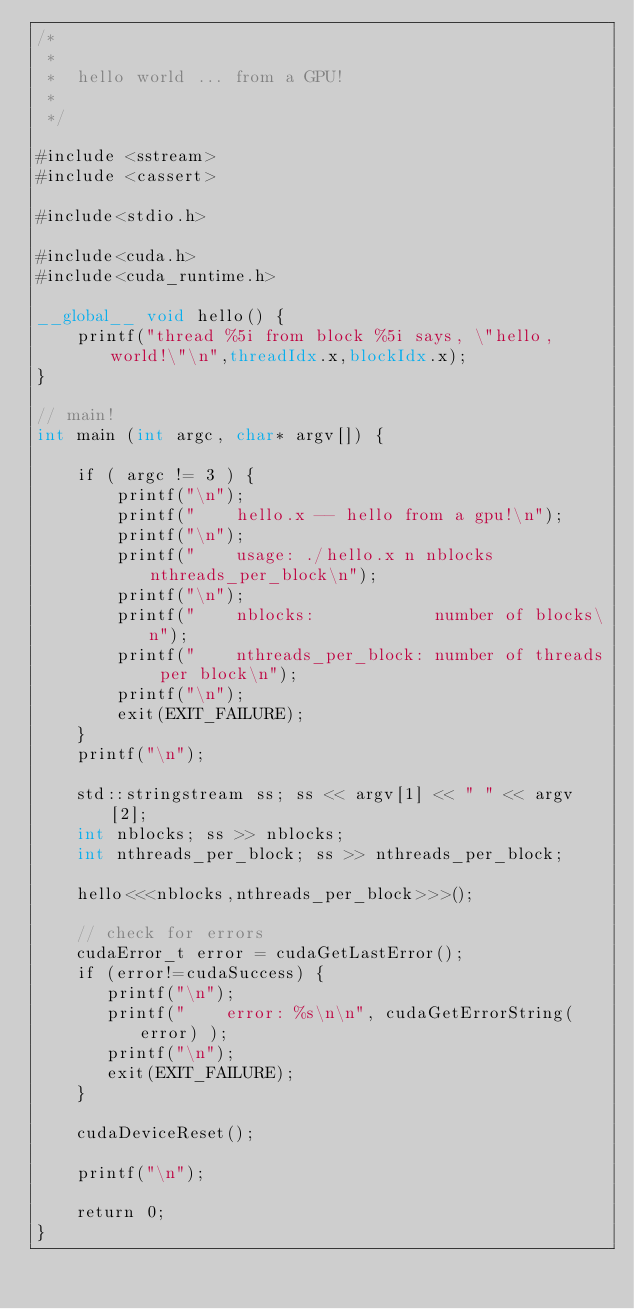<code> <loc_0><loc_0><loc_500><loc_500><_Cuda_>/* 
 *
 *  hello world ... from a GPU!
 *
 */

#include <sstream>
#include <cassert>

#include<stdio.h>

#include<cuda.h>
#include<cuda_runtime.h>

__global__ void hello() {
    printf("thread %5i from block %5i says, \"hello, world!\"\n",threadIdx.x,blockIdx.x);
}

// main!
int main (int argc, char* argv[]) {

    if ( argc != 3 ) {
        printf("\n");
        printf("    hello.x -- hello from a gpu!\n");
        printf("\n");
        printf("    usage: ./hello.x n nblocks nthreads_per_block\n");
        printf("\n");
        printf("    nblocks:            number of blocks\n");
        printf("    nthreads_per_block: number of threads per block\n");
        printf("\n");
        exit(EXIT_FAILURE);
    }
    printf("\n");

    std::stringstream ss; ss << argv[1] << " " << argv[2];
    int nblocks; ss >> nblocks;
    int nthreads_per_block; ss >> nthreads_per_block;

    hello<<<nblocks,nthreads_per_block>>>();

    // check for errors
    cudaError_t error = cudaGetLastError();
    if (error!=cudaSuccess) {
       printf("\n");
       printf("    error: %s\n\n", cudaGetErrorString(error) );
       printf("\n");
       exit(EXIT_FAILURE);
    }

    cudaDeviceReset();

    printf("\n");

    return 0;
}
</code> 